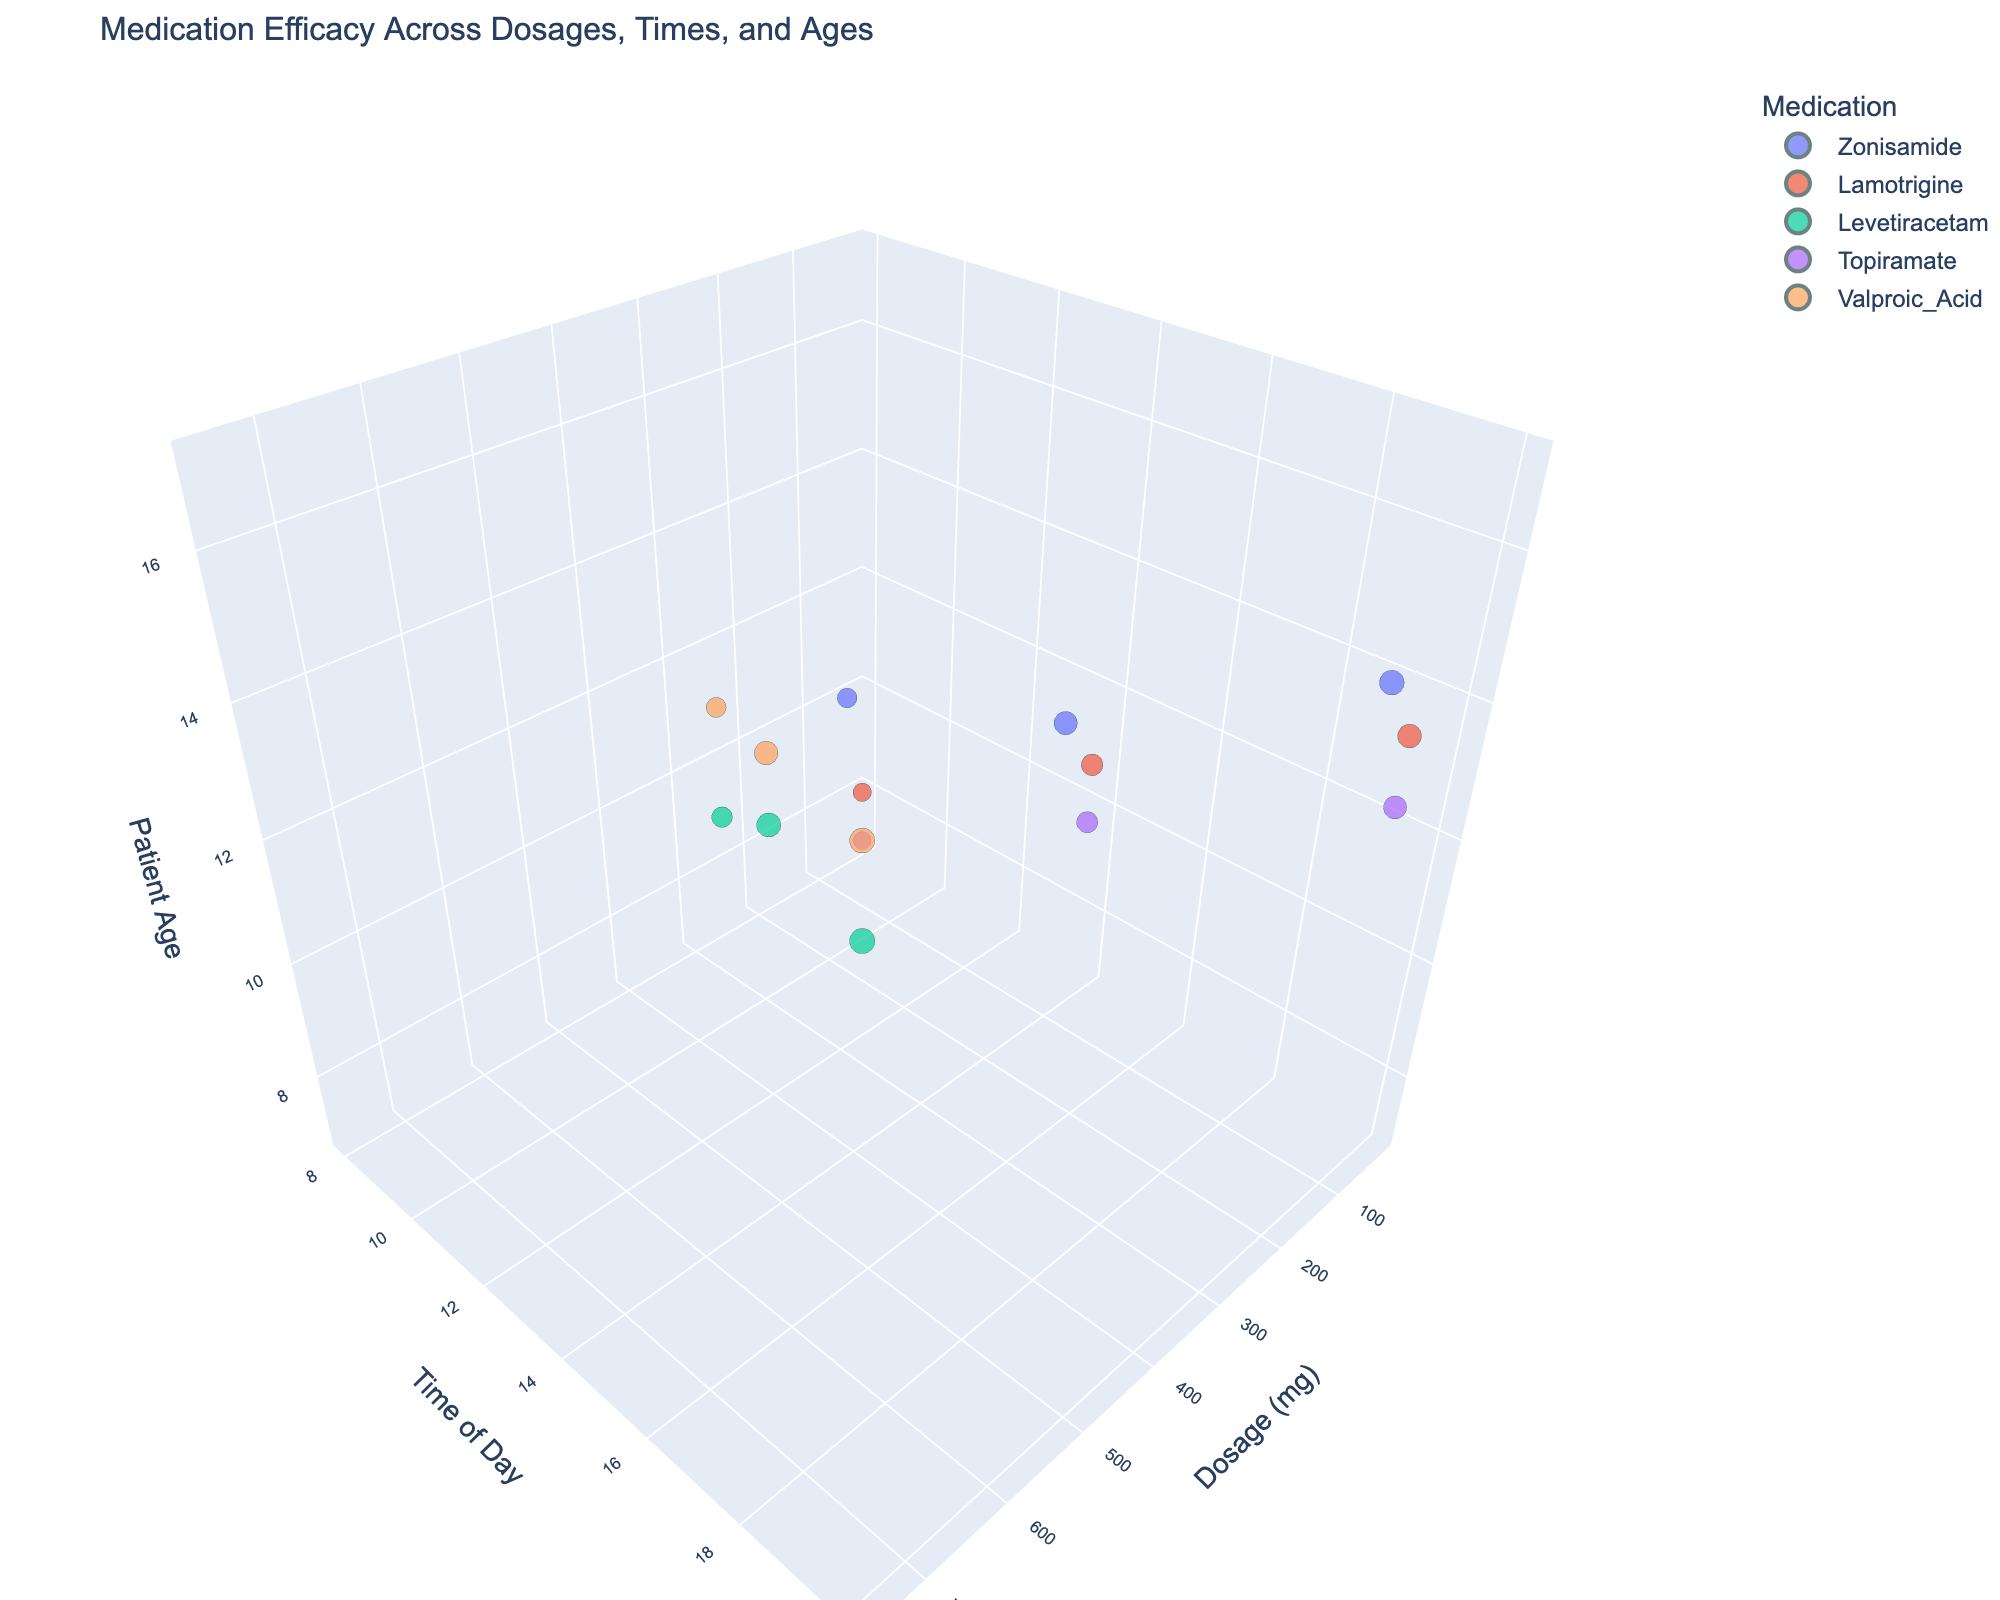What is the color scale used for the medication categories? The color of the markers representing different medications is derived from the Viridis color scale, visible by examining the legend next to each point cluster in the plot.
Answer: Viridis What does the size of the markers represent in the plot? By observing the figure and checking the legend or hover data, we can see that the size of the markers corresponds to the Efficacy Score of the medication.
Answer: Efficacy Score Which medication has the highest efficacy score based on the size of the markers? By examining the plot, we look for the largest markers among all medication categories; the largest markers correspond to Zonisamide, Levetiracetam, and Valproic Acid, indicating these medications have the highest efficacy scores.
Answer: Zonisamide, Levetiracetam, and Valproic Acid At what time of day does the highest dosage of Topiramate show in the plot, and what is its efficacy score size? We navigate the 3D scatter plot to identify the highest dosage of Topiramate, which is 100 mg at 20:00, and examine its marker size using hover data that reveal its efficacy score.
Answer: 20:00; 4.4 How does the efficacy score of Lamotrigine at 14:00 compare to that of Levetiracetam at the same time? We locate both Lamotrigine and Levetiracetam on the 14:00 axis, note the sizes of their markers, and compare them. Lamotrigine (50mg) has an efficacy score of 3.9, while Levetiracetam (500mg) has an efficacy score of 4.8.
Answer: Levetiracetam has a higher efficacy score Which patient age group exhibits the highest overall efficacy score, regardless of medication? We scan the plot for the largest markers across different age groups, noting that the largest markers consistently appear around the age group of 17.
Answer: Age 17 Are there any medications with overlapping time of day and dosage but different patient age groups? By comparing marker positions in a 3D perspective, we find medications like Zonisamide (at dosage 100mg, time 14:00) and Levetiracetam, also at dosage 500mg and time 14:00, but different patient age groups (Zonisamide 12, Levetiracetam 13).
Answer: Yes, Zonisamide and Levetiracetam At what dosage and time of day does Valproic Acid show its efficacy for the oldest patient group? We identify the oldest patient group (age 17) and locate Valproic Acid markers to see their corresponding dosage and time of day. It shows dosage 750mg and time 20:00.
Answer: 750mg; 20:00 